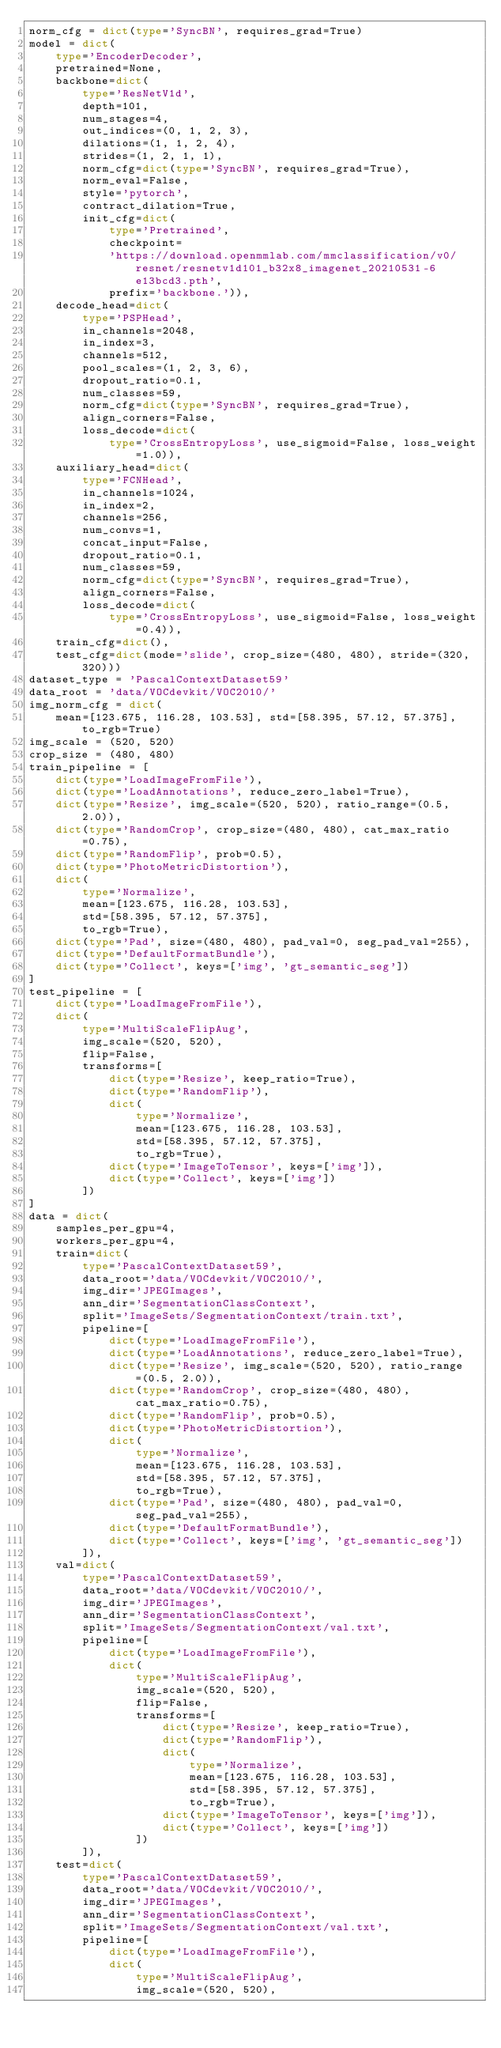<code> <loc_0><loc_0><loc_500><loc_500><_Python_>norm_cfg = dict(type='SyncBN', requires_grad=True)
model = dict(
    type='EncoderDecoder',
    pretrained=None,
    backbone=dict(
        type='ResNetV1d',
        depth=101,
        num_stages=4,
        out_indices=(0, 1, 2, 3),
        dilations=(1, 1, 2, 4),
        strides=(1, 2, 1, 1),
        norm_cfg=dict(type='SyncBN', requires_grad=True),
        norm_eval=False,
        style='pytorch',
        contract_dilation=True,
        init_cfg=dict(
            type='Pretrained',
            checkpoint=
            'https://download.openmmlab.com/mmclassification/v0/resnet/resnetv1d101_b32x8_imagenet_20210531-6e13bcd3.pth',
            prefix='backbone.')),
    decode_head=dict(
        type='PSPHead',
        in_channels=2048,
        in_index=3,
        channels=512,
        pool_scales=(1, 2, 3, 6),
        dropout_ratio=0.1,
        num_classes=59,
        norm_cfg=dict(type='SyncBN', requires_grad=True),
        align_corners=False,
        loss_decode=dict(
            type='CrossEntropyLoss', use_sigmoid=False, loss_weight=1.0)),
    auxiliary_head=dict(
        type='FCNHead',
        in_channels=1024,
        in_index=2,
        channels=256,
        num_convs=1,
        concat_input=False,
        dropout_ratio=0.1,
        num_classes=59,
        norm_cfg=dict(type='SyncBN', requires_grad=True),
        align_corners=False,
        loss_decode=dict(
            type='CrossEntropyLoss', use_sigmoid=False, loss_weight=0.4)),
    train_cfg=dict(),
    test_cfg=dict(mode='slide', crop_size=(480, 480), stride=(320, 320)))
dataset_type = 'PascalContextDataset59'
data_root = 'data/VOCdevkit/VOC2010/'
img_norm_cfg = dict(
    mean=[123.675, 116.28, 103.53], std=[58.395, 57.12, 57.375], to_rgb=True)
img_scale = (520, 520)
crop_size = (480, 480)
train_pipeline = [
    dict(type='LoadImageFromFile'),
    dict(type='LoadAnnotations', reduce_zero_label=True),
    dict(type='Resize', img_scale=(520, 520), ratio_range=(0.5, 2.0)),
    dict(type='RandomCrop', crop_size=(480, 480), cat_max_ratio=0.75),
    dict(type='RandomFlip', prob=0.5),
    dict(type='PhotoMetricDistortion'),
    dict(
        type='Normalize',
        mean=[123.675, 116.28, 103.53],
        std=[58.395, 57.12, 57.375],
        to_rgb=True),
    dict(type='Pad', size=(480, 480), pad_val=0, seg_pad_val=255),
    dict(type='DefaultFormatBundle'),
    dict(type='Collect', keys=['img', 'gt_semantic_seg'])
]
test_pipeline = [
    dict(type='LoadImageFromFile'),
    dict(
        type='MultiScaleFlipAug',
        img_scale=(520, 520),
        flip=False,
        transforms=[
            dict(type='Resize', keep_ratio=True),
            dict(type='RandomFlip'),
            dict(
                type='Normalize',
                mean=[123.675, 116.28, 103.53],
                std=[58.395, 57.12, 57.375],
                to_rgb=True),
            dict(type='ImageToTensor', keys=['img']),
            dict(type='Collect', keys=['img'])
        ])
]
data = dict(
    samples_per_gpu=4,
    workers_per_gpu=4,
    train=dict(
        type='PascalContextDataset59',
        data_root='data/VOCdevkit/VOC2010/',
        img_dir='JPEGImages',
        ann_dir='SegmentationClassContext',
        split='ImageSets/SegmentationContext/train.txt',
        pipeline=[
            dict(type='LoadImageFromFile'),
            dict(type='LoadAnnotations', reduce_zero_label=True),
            dict(type='Resize', img_scale=(520, 520), ratio_range=(0.5, 2.0)),
            dict(type='RandomCrop', crop_size=(480, 480), cat_max_ratio=0.75),
            dict(type='RandomFlip', prob=0.5),
            dict(type='PhotoMetricDistortion'),
            dict(
                type='Normalize',
                mean=[123.675, 116.28, 103.53],
                std=[58.395, 57.12, 57.375],
                to_rgb=True),
            dict(type='Pad', size=(480, 480), pad_val=0, seg_pad_val=255),
            dict(type='DefaultFormatBundle'),
            dict(type='Collect', keys=['img', 'gt_semantic_seg'])
        ]),
    val=dict(
        type='PascalContextDataset59',
        data_root='data/VOCdevkit/VOC2010/',
        img_dir='JPEGImages',
        ann_dir='SegmentationClassContext',
        split='ImageSets/SegmentationContext/val.txt',
        pipeline=[
            dict(type='LoadImageFromFile'),
            dict(
                type='MultiScaleFlipAug',
                img_scale=(520, 520),
                flip=False,
                transforms=[
                    dict(type='Resize', keep_ratio=True),
                    dict(type='RandomFlip'),
                    dict(
                        type='Normalize',
                        mean=[123.675, 116.28, 103.53],
                        std=[58.395, 57.12, 57.375],
                        to_rgb=True),
                    dict(type='ImageToTensor', keys=['img']),
                    dict(type='Collect', keys=['img'])
                ])
        ]),
    test=dict(
        type='PascalContextDataset59',
        data_root='data/VOCdevkit/VOC2010/',
        img_dir='JPEGImages',
        ann_dir='SegmentationClassContext',
        split='ImageSets/SegmentationContext/val.txt',
        pipeline=[
            dict(type='LoadImageFromFile'),
            dict(
                type='MultiScaleFlipAug',
                img_scale=(520, 520),</code> 